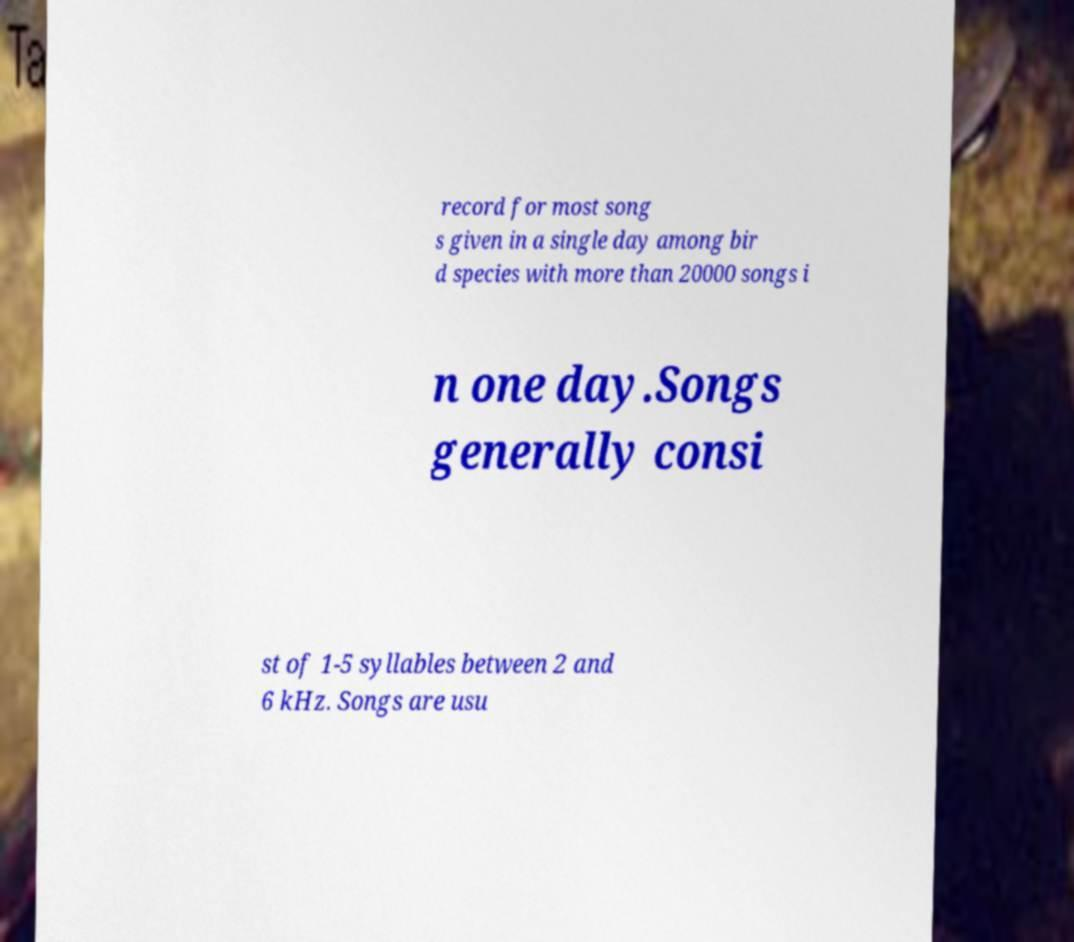I need the written content from this picture converted into text. Can you do that? record for most song s given in a single day among bir d species with more than 20000 songs i n one day.Songs generally consi st of 1-5 syllables between 2 and 6 kHz. Songs are usu 